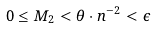<formula> <loc_0><loc_0><loc_500><loc_500>0 \leq M _ { 2 } < { \theta } \cdot { n ^ { - 2 } } < \epsilon</formula> 